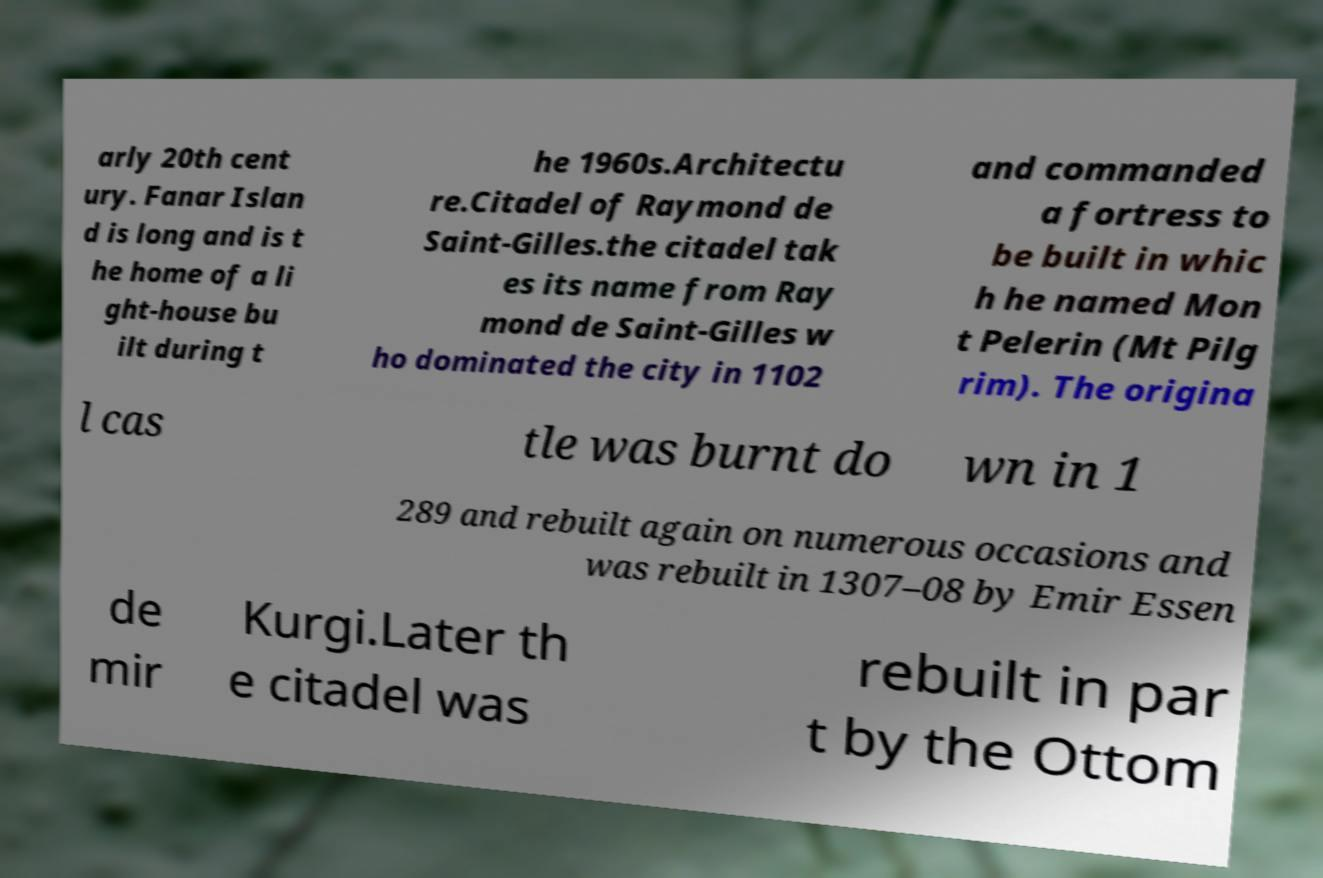There's text embedded in this image that I need extracted. Can you transcribe it verbatim? arly 20th cent ury. Fanar Islan d is long and is t he home of a li ght-house bu ilt during t he 1960s.Architectu re.Citadel of Raymond de Saint-Gilles.the citadel tak es its name from Ray mond de Saint-Gilles w ho dominated the city in 1102 and commanded a fortress to be built in whic h he named Mon t Pelerin (Mt Pilg rim). The origina l cas tle was burnt do wn in 1 289 and rebuilt again on numerous occasions and was rebuilt in 1307–08 by Emir Essen de mir Kurgi.Later th e citadel was rebuilt in par t by the Ottom 